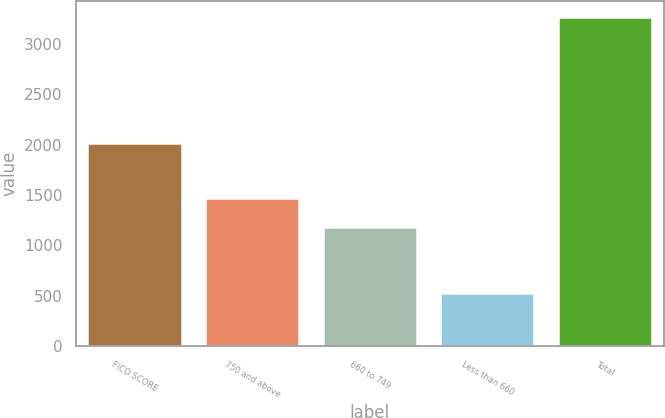Convert chart. <chart><loc_0><loc_0><loc_500><loc_500><bar_chart><fcel>FICO SCORE<fcel>750 and above<fcel>660 to 749<fcel>Less than 660<fcel>Total<nl><fcel>2017<fcel>1472<fcel>1184<fcel>529<fcel>3261<nl></chart> 